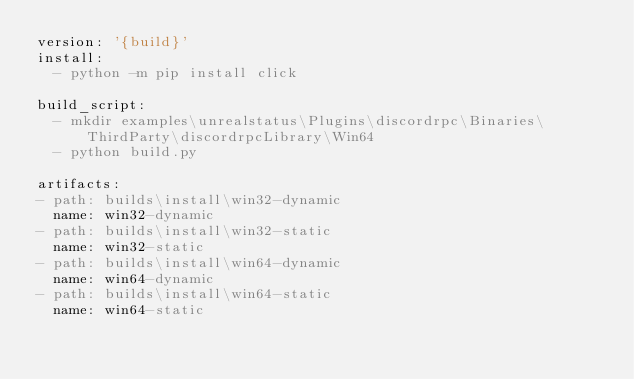<code> <loc_0><loc_0><loc_500><loc_500><_YAML_>version: '{build}'
install:
  - python -m pip install click

build_script:
  - mkdir examples\unrealstatus\Plugins\discordrpc\Binaries\ThirdParty\discordrpcLibrary\Win64
  - python build.py

artifacts:
- path: builds\install\win32-dynamic
  name: win32-dynamic
- path: builds\install\win32-static
  name: win32-static
- path: builds\install\win64-dynamic
  name: win64-dynamic
- path: builds\install\win64-static
  name: win64-static
</code> 